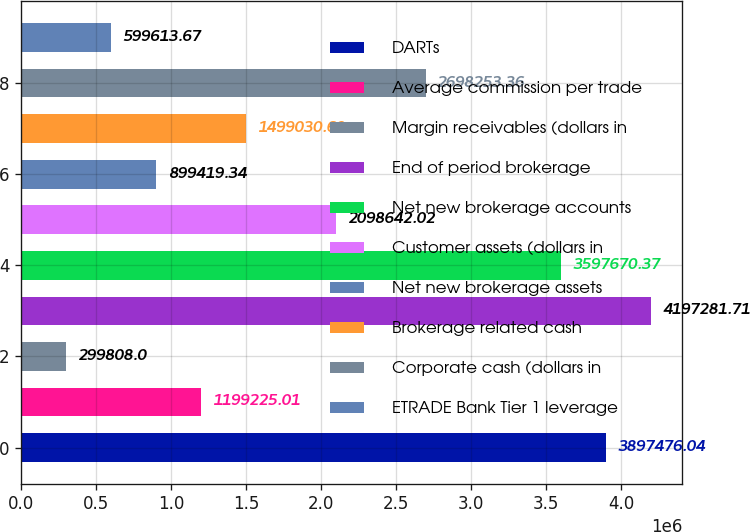<chart> <loc_0><loc_0><loc_500><loc_500><bar_chart><fcel>DARTs<fcel>Average commission per trade<fcel>Margin receivables (dollars in<fcel>End of period brokerage<fcel>Net new brokerage accounts<fcel>Customer assets (dollars in<fcel>Net new brokerage assets<fcel>Brokerage related cash<fcel>Corporate cash (dollars in<fcel>ETRADE Bank Tier 1 leverage<nl><fcel>3.89748e+06<fcel>1.19923e+06<fcel>299808<fcel>4.19728e+06<fcel>3.59767e+06<fcel>2.09864e+06<fcel>899419<fcel>1.49903e+06<fcel>2.69825e+06<fcel>599614<nl></chart> 